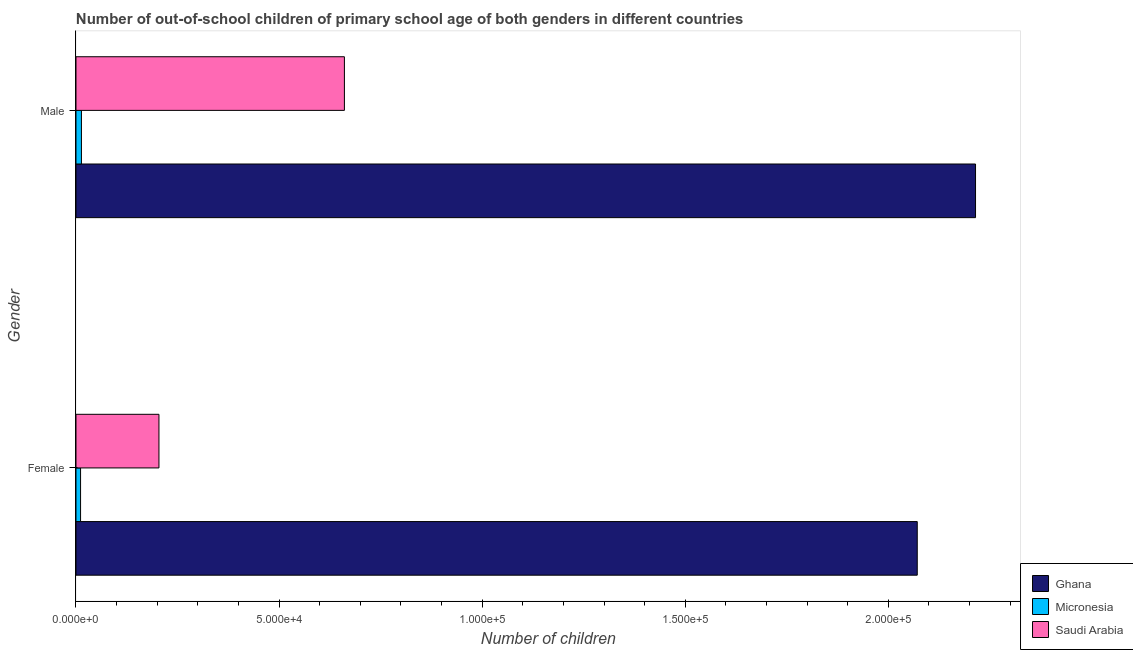Are the number of bars on each tick of the Y-axis equal?
Give a very brief answer. Yes. What is the number of male out-of-school students in Ghana?
Your answer should be compact. 2.21e+05. Across all countries, what is the maximum number of female out-of-school students?
Offer a terse response. 2.07e+05. Across all countries, what is the minimum number of female out-of-school students?
Provide a short and direct response. 1127. In which country was the number of female out-of-school students maximum?
Provide a short and direct response. Ghana. In which country was the number of female out-of-school students minimum?
Your response must be concise. Micronesia. What is the total number of female out-of-school students in the graph?
Your response must be concise. 2.29e+05. What is the difference between the number of female out-of-school students in Saudi Arabia and that in Ghana?
Your answer should be compact. -1.87e+05. What is the difference between the number of male out-of-school students in Ghana and the number of female out-of-school students in Micronesia?
Give a very brief answer. 2.20e+05. What is the average number of male out-of-school students per country?
Make the answer very short. 9.63e+04. What is the difference between the number of male out-of-school students and number of female out-of-school students in Saudi Arabia?
Make the answer very short. 4.57e+04. In how many countries, is the number of male out-of-school students greater than 180000 ?
Give a very brief answer. 1. What is the ratio of the number of male out-of-school students in Saudi Arabia to that in Ghana?
Your answer should be compact. 0.3. In how many countries, is the number of female out-of-school students greater than the average number of female out-of-school students taken over all countries?
Provide a short and direct response. 1. What does the 1st bar from the top in Female represents?
Offer a very short reply. Saudi Arabia. What does the 1st bar from the bottom in Female represents?
Ensure brevity in your answer.  Ghana. Are all the bars in the graph horizontal?
Provide a short and direct response. Yes. How many countries are there in the graph?
Provide a succinct answer. 3. Are the values on the major ticks of X-axis written in scientific E-notation?
Ensure brevity in your answer.  Yes. Does the graph contain grids?
Give a very brief answer. No. Where does the legend appear in the graph?
Your answer should be compact. Bottom right. What is the title of the graph?
Keep it short and to the point. Number of out-of-school children of primary school age of both genders in different countries. Does "Germany" appear as one of the legend labels in the graph?
Make the answer very short. No. What is the label or title of the X-axis?
Provide a short and direct response. Number of children. What is the Number of children of Ghana in Female?
Provide a short and direct response. 2.07e+05. What is the Number of children in Micronesia in Female?
Make the answer very short. 1127. What is the Number of children of Saudi Arabia in Female?
Offer a very short reply. 2.04e+04. What is the Number of children of Ghana in Male?
Offer a terse response. 2.21e+05. What is the Number of children in Micronesia in Male?
Provide a succinct answer. 1343. What is the Number of children in Saudi Arabia in Male?
Give a very brief answer. 6.61e+04. Across all Gender, what is the maximum Number of children of Ghana?
Make the answer very short. 2.21e+05. Across all Gender, what is the maximum Number of children in Micronesia?
Make the answer very short. 1343. Across all Gender, what is the maximum Number of children in Saudi Arabia?
Keep it short and to the point. 6.61e+04. Across all Gender, what is the minimum Number of children of Ghana?
Provide a short and direct response. 2.07e+05. Across all Gender, what is the minimum Number of children of Micronesia?
Provide a succinct answer. 1127. Across all Gender, what is the minimum Number of children of Saudi Arabia?
Make the answer very short. 2.04e+04. What is the total Number of children in Ghana in the graph?
Your response must be concise. 4.29e+05. What is the total Number of children in Micronesia in the graph?
Ensure brevity in your answer.  2470. What is the total Number of children in Saudi Arabia in the graph?
Provide a short and direct response. 8.65e+04. What is the difference between the Number of children of Ghana in Female and that in Male?
Ensure brevity in your answer.  -1.43e+04. What is the difference between the Number of children in Micronesia in Female and that in Male?
Your response must be concise. -216. What is the difference between the Number of children of Saudi Arabia in Female and that in Male?
Offer a terse response. -4.57e+04. What is the difference between the Number of children in Ghana in Female and the Number of children in Micronesia in Male?
Your response must be concise. 2.06e+05. What is the difference between the Number of children in Ghana in Female and the Number of children in Saudi Arabia in Male?
Your answer should be compact. 1.41e+05. What is the difference between the Number of children in Micronesia in Female and the Number of children in Saudi Arabia in Male?
Offer a very short reply. -6.50e+04. What is the average Number of children in Ghana per Gender?
Your answer should be compact. 2.14e+05. What is the average Number of children in Micronesia per Gender?
Make the answer very short. 1235. What is the average Number of children in Saudi Arabia per Gender?
Offer a terse response. 4.33e+04. What is the difference between the Number of children of Ghana and Number of children of Micronesia in Female?
Offer a terse response. 2.06e+05. What is the difference between the Number of children in Ghana and Number of children in Saudi Arabia in Female?
Your answer should be very brief. 1.87e+05. What is the difference between the Number of children in Micronesia and Number of children in Saudi Arabia in Female?
Offer a very short reply. -1.93e+04. What is the difference between the Number of children of Ghana and Number of children of Micronesia in Male?
Your answer should be compact. 2.20e+05. What is the difference between the Number of children in Ghana and Number of children in Saudi Arabia in Male?
Provide a succinct answer. 1.55e+05. What is the difference between the Number of children of Micronesia and Number of children of Saudi Arabia in Male?
Offer a terse response. -6.47e+04. What is the ratio of the Number of children of Ghana in Female to that in Male?
Your answer should be compact. 0.94. What is the ratio of the Number of children in Micronesia in Female to that in Male?
Provide a short and direct response. 0.84. What is the ratio of the Number of children in Saudi Arabia in Female to that in Male?
Your answer should be compact. 0.31. What is the difference between the highest and the second highest Number of children of Ghana?
Give a very brief answer. 1.43e+04. What is the difference between the highest and the second highest Number of children of Micronesia?
Provide a short and direct response. 216. What is the difference between the highest and the second highest Number of children of Saudi Arabia?
Your response must be concise. 4.57e+04. What is the difference between the highest and the lowest Number of children of Ghana?
Your answer should be very brief. 1.43e+04. What is the difference between the highest and the lowest Number of children in Micronesia?
Make the answer very short. 216. What is the difference between the highest and the lowest Number of children in Saudi Arabia?
Your answer should be very brief. 4.57e+04. 